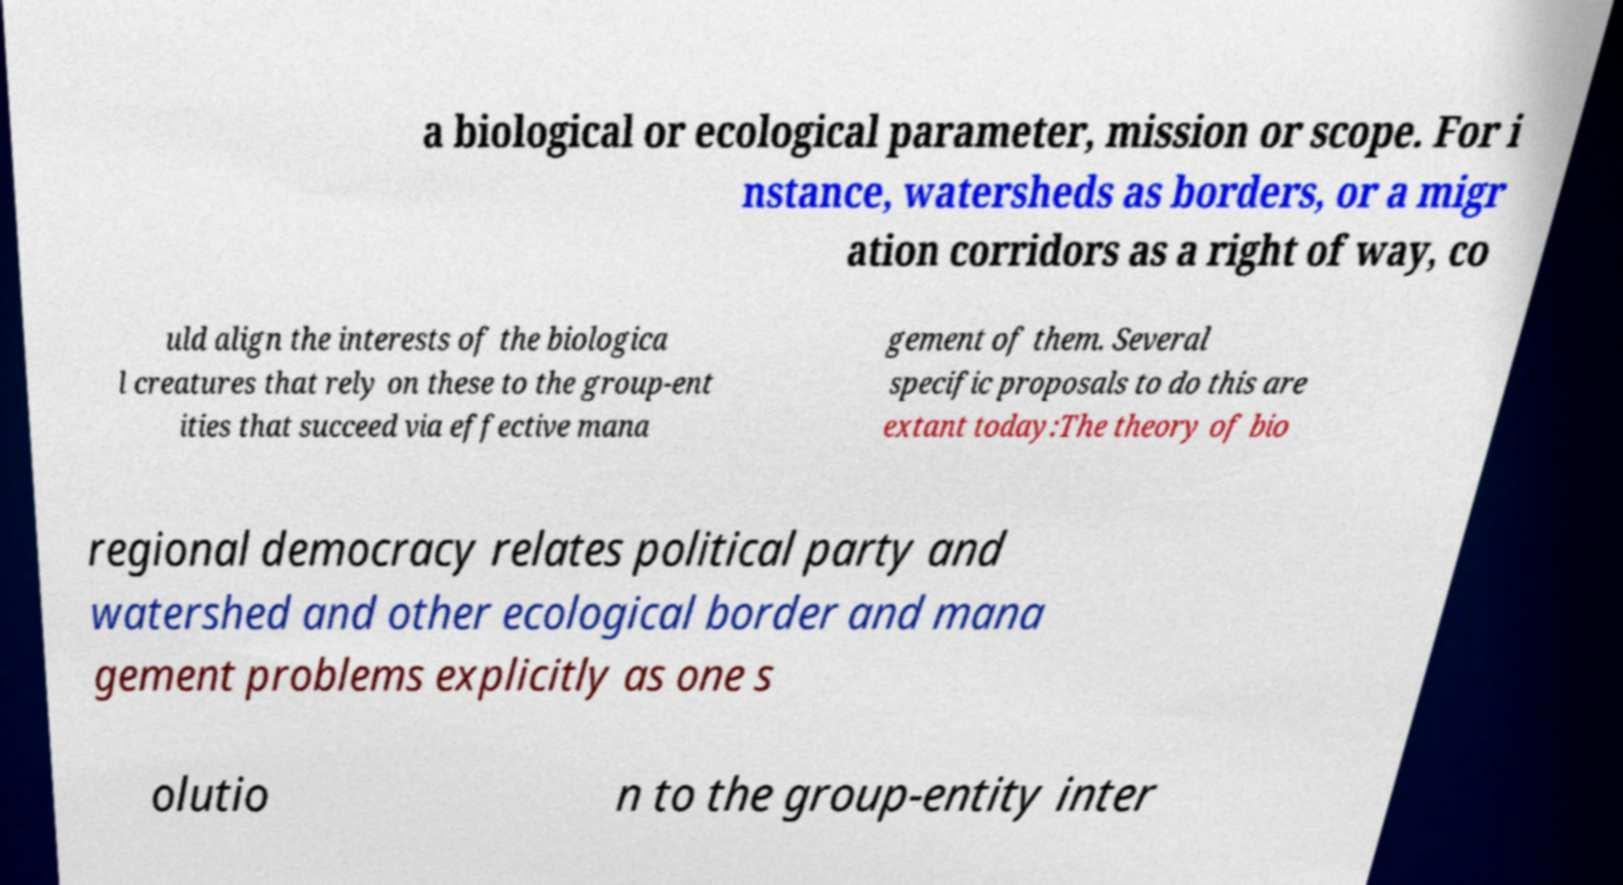Could you extract and type out the text from this image? a biological or ecological parameter, mission or scope. For i nstance, watersheds as borders, or a migr ation corridors as a right of way, co uld align the interests of the biologica l creatures that rely on these to the group-ent ities that succeed via effective mana gement of them. Several specific proposals to do this are extant today:The theory of bio regional democracy relates political party and watershed and other ecological border and mana gement problems explicitly as one s olutio n to the group-entity inter 